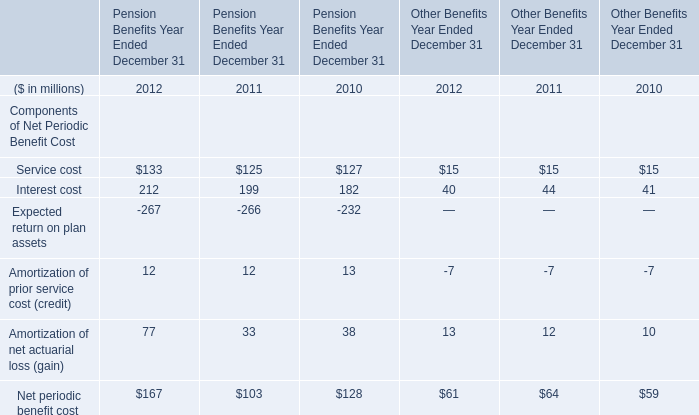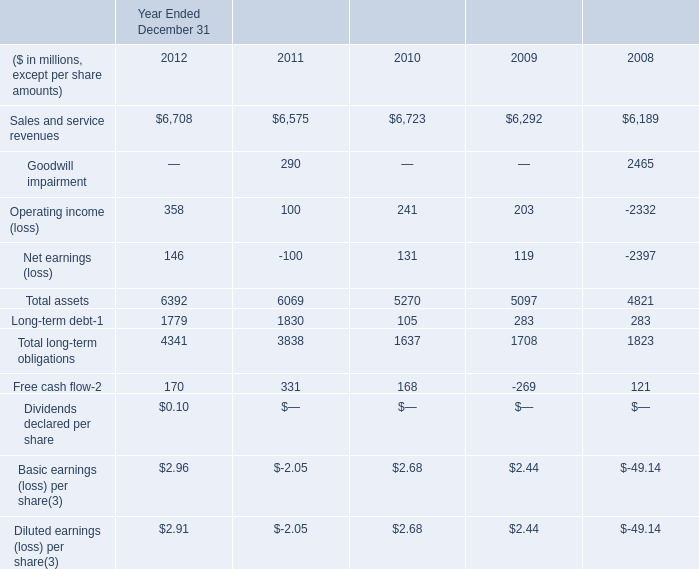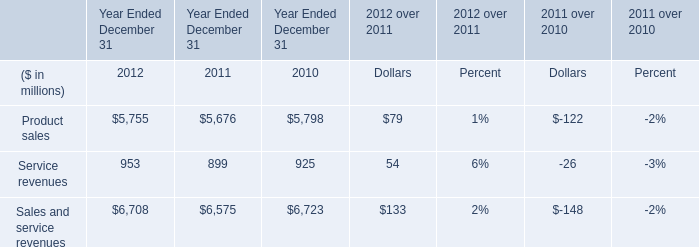what's the total amount of Goodwill impairment of Year Ended December 31 2008, Product sales of Year Ended December 31 2010, and Sales and service revenues of Year Ended December 31 2012 ? 
Computations: ((2465.0 + 5798.0) + 6708.0)
Answer: 14971.0. 